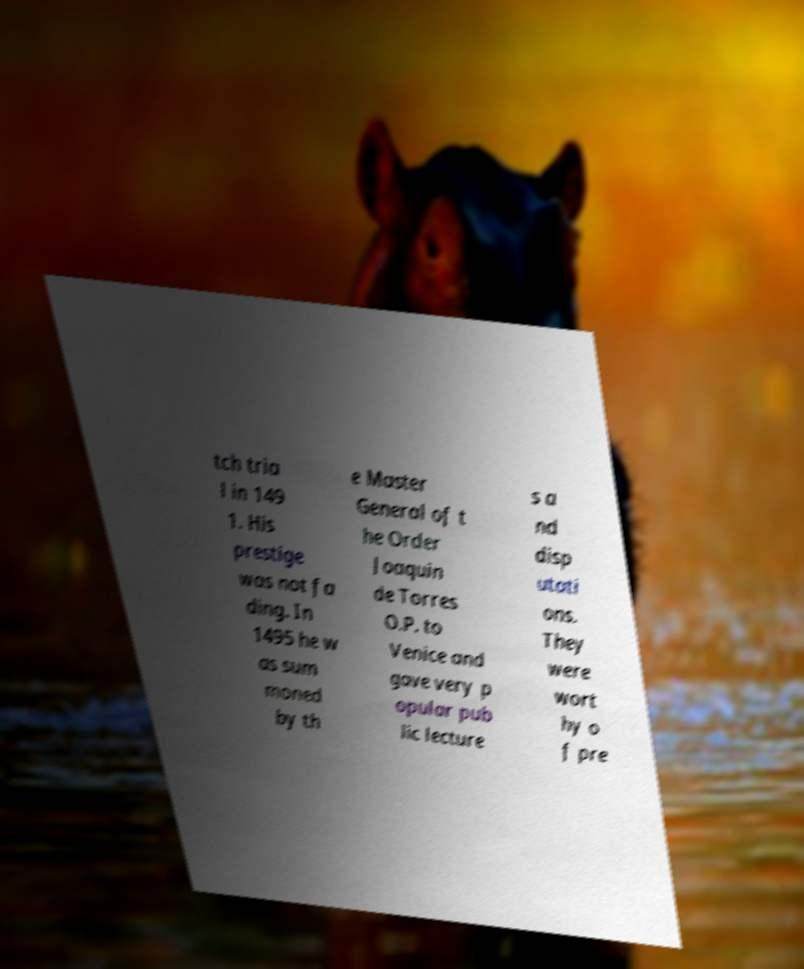Can you read and provide the text displayed in the image?This photo seems to have some interesting text. Can you extract and type it out for me? tch tria l in 149 1. His prestige was not fa ding. In 1495 he w as sum moned by th e Master General of t he Order Joaquin de Torres O.P. to Venice and gave very p opular pub lic lecture s a nd disp utati ons. They were wort hy o f pre 